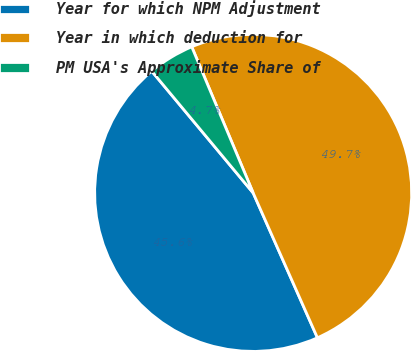Convert chart to OTSL. <chart><loc_0><loc_0><loc_500><loc_500><pie_chart><fcel>Year for which NPM Adjustment<fcel>Year in which deduction for<fcel>PM USA's Approximate Share of<nl><fcel>45.59%<fcel>49.69%<fcel>4.72%<nl></chart> 